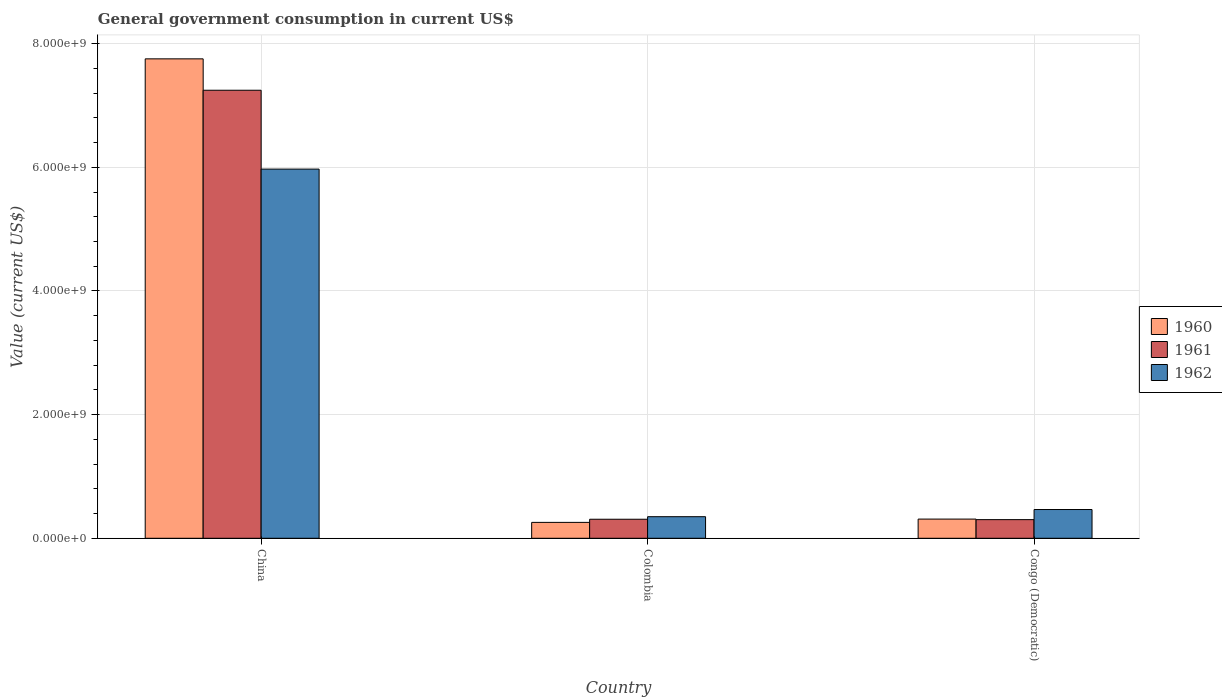How many different coloured bars are there?
Ensure brevity in your answer.  3. Are the number of bars on each tick of the X-axis equal?
Keep it short and to the point. Yes. How many bars are there on the 2nd tick from the right?
Provide a succinct answer. 3. In how many cases, is the number of bars for a given country not equal to the number of legend labels?
Provide a succinct answer. 0. What is the government conusmption in 1962 in Congo (Democratic)?
Give a very brief answer. 4.65e+08. Across all countries, what is the maximum government conusmption in 1960?
Give a very brief answer. 7.75e+09. Across all countries, what is the minimum government conusmption in 1961?
Make the answer very short. 3.02e+08. In which country was the government conusmption in 1960 maximum?
Offer a terse response. China. In which country was the government conusmption in 1961 minimum?
Your answer should be compact. Congo (Democratic). What is the total government conusmption in 1960 in the graph?
Provide a succinct answer. 8.32e+09. What is the difference between the government conusmption in 1960 in China and that in Congo (Democratic)?
Offer a terse response. 7.44e+09. What is the difference between the government conusmption in 1962 in China and the government conusmption in 1960 in Congo (Democratic)?
Offer a very short reply. 5.66e+09. What is the average government conusmption in 1962 per country?
Offer a terse response. 2.26e+09. What is the difference between the government conusmption of/in 1962 and government conusmption of/in 1960 in China?
Your answer should be compact. -1.78e+09. In how many countries, is the government conusmption in 1962 greater than 1600000000 US$?
Keep it short and to the point. 1. What is the ratio of the government conusmption in 1962 in China to that in Congo (Democratic)?
Offer a very short reply. 12.84. Is the difference between the government conusmption in 1962 in Colombia and Congo (Democratic) greater than the difference between the government conusmption in 1960 in Colombia and Congo (Democratic)?
Provide a succinct answer. No. What is the difference between the highest and the second highest government conusmption in 1960?
Keep it short and to the point. 7.44e+09. What is the difference between the highest and the lowest government conusmption in 1962?
Provide a succinct answer. 5.62e+09. In how many countries, is the government conusmption in 1962 greater than the average government conusmption in 1962 taken over all countries?
Your response must be concise. 1. What does the 2nd bar from the left in Colombia represents?
Give a very brief answer. 1961. Is it the case that in every country, the sum of the government conusmption in 1960 and government conusmption in 1962 is greater than the government conusmption in 1961?
Make the answer very short. Yes. Are all the bars in the graph horizontal?
Your answer should be compact. No. How many countries are there in the graph?
Your answer should be very brief. 3. Does the graph contain grids?
Your answer should be compact. Yes. Where does the legend appear in the graph?
Provide a short and direct response. Center right. How many legend labels are there?
Offer a very short reply. 3. What is the title of the graph?
Offer a terse response. General government consumption in current US$. Does "2011" appear as one of the legend labels in the graph?
Make the answer very short. No. What is the label or title of the X-axis?
Make the answer very short. Country. What is the label or title of the Y-axis?
Make the answer very short. Value (current US$). What is the Value (current US$) of 1960 in China?
Offer a terse response. 7.75e+09. What is the Value (current US$) in 1961 in China?
Provide a succinct answer. 7.25e+09. What is the Value (current US$) in 1962 in China?
Offer a terse response. 5.97e+09. What is the Value (current US$) of 1960 in Colombia?
Your response must be concise. 2.57e+08. What is the Value (current US$) of 1961 in Colombia?
Offer a terse response. 3.08e+08. What is the Value (current US$) in 1962 in Colombia?
Offer a very short reply. 3.49e+08. What is the Value (current US$) in 1960 in Congo (Democratic)?
Provide a short and direct response. 3.11e+08. What is the Value (current US$) in 1961 in Congo (Democratic)?
Provide a short and direct response. 3.02e+08. What is the Value (current US$) of 1962 in Congo (Democratic)?
Offer a terse response. 4.65e+08. Across all countries, what is the maximum Value (current US$) of 1960?
Your response must be concise. 7.75e+09. Across all countries, what is the maximum Value (current US$) in 1961?
Your answer should be compact. 7.25e+09. Across all countries, what is the maximum Value (current US$) of 1962?
Provide a short and direct response. 5.97e+09. Across all countries, what is the minimum Value (current US$) in 1960?
Provide a succinct answer. 2.57e+08. Across all countries, what is the minimum Value (current US$) in 1961?
Give a very brief answer. 3.02e+08. Across all countries, what is the minimum Value (current US$) of 1962?
Your answer should be compact. 3.49e+08. What is the total Value (current US$) of 1960 in the graph?
Make the answer very short. 8.32e+09. What is the total Value (current US$) of 1961 in the graph?
Make the answer very short. 7.86e+09. What is the total Value (current US$) in 1962 in the graph?
Your answer should be very brief. 6.79e+09. What is the difference between the Value (current US$) in 1960 in China and that in Colombia?
Provide a succinct answer. 7.50e+09. What is the difference between the Value (current US$) of 1961 in China and that in Colombia?
Your response must be concise. 6.94e+09. What is the difference between the Value (current US$) of 1962 in China and that in Colombia?
Offer a terse response. 5.62e+09. What is the difference between the Value (current US$) in 1960 in China and that in Congo (Democratic)?
Offer a terse response. 7.44e+09. What is the difference between the Value (current US$) of 1961 in China and that in Congo (Democratic)?
Give a very brief answer. 6.95e+09. What is the difference between the Value (current US$) in 1962 in China and that in Congo (Democratic)?
Keep it short and to the point. 5.51e+09. What is the difference between the Value (current US$) in 1960 in Colombia and that in Congo (Democratic)?
Provide a short and direct response. -5.35e+07. What is the difference between the Value (current US$) of 1961 in Colombia and that in Congo (Democratic)?
Keep it short and to the point. 6.24e+06. What is the difference between the Value (current US$) in 1962 in Colombia and that in Congo (Democratic)?
Your answer should be compact. -1.16e+08. What is the difference between the Value (current US$) in 1960 in China and the Value (current US$) in 1961 in Colombia?
Give a very brief answer. 7.45e+09. What is the difference between the Value (current US$) in 1960 in China and the Value (current US$) in 1962 in Colombia?
Keep it short and to the point. 7.41e+09. What is the difference between the Value (current US$) in 1961 in China and the Value (current US$) in 1962 in Colombia?
Make the answer very short. 6.90e+09. What is the difference between the Value (current US$) in 1960 in China and the Value (current US$) in 1961 in Congo (Democratic)?
Offer a terse response. 7.45e+09. What is the difference between the Value (current US$) of 1960 in China and the Value (current US$) of 1962 in Congo (Democratic)?
Your answer should be very brief. 7.29e+09. What is the difference between the Value (current US$) of 1961 in China and the Value (current US$) of 1962 in Congo (Democratic)?
Provide a succinct answer. 6.78e+09. What is the difference between the Value (current US$) of 1960 in Colombia and the Value (current US$) of 1961 in Congo (Democratic)?
Offer a terse response. -4.46e+07. What is the difference between the Value (current US$) in 1960 in Colombia and the Value (current US$) in 1962 in Congo (Democratic)?
Provide a short and direct response. -2.08e+08. What is the difference between the Value (current US$) of 1961 in Colombia and the Value (current US$) of 1962 in Congo (Democratic)?
Your answer should be compact. -1.57e+08. What is the average Value (current US$) in 1960 per country?
Offer a terse response. 2.77e+09. What is the average Value (current US$) in 1961 per country?
Offer a terse response. 2.62e+09. What is the average Value (current US$) in 1962 per country?
Ensure brevity in your answer.  2.26e+09. What is the difference between the Value (current US$) in 1960 and Value (current US$) in 1961 in China?
Your answer should be very brief. 5.08e+08. What is the difference between the Value (current US$) in 1960 and Value (current US$) in 1962 in China?
Your answer should be compact. 1.78e+09. What is the difference between the Value (current US$) of 1961 and Value (current US$) of 1962 in China?
Offer a very short reply. 1.28e+09. What is the difference between the Value (current US$) in 1960 and Value (current US$) in 1961 in Colombia?
Your response must be concise. -5.09e+07. What is the difference between the Value (current US$) of 1960 and Value (current US$) of 1962 in Colombia?
Give a very brief answer. -9.22e+07. What is the difference between the Value (current US$) of 1961 and Value (current US$) of 1962 in Colombia?
Give a very brief answer. -4.13e+07. What is the difference between the Value (current US$) in 1960 and Value (current US$) in 1961 in Congo (Democratic)?
Give a very brief answer. 8.87e+06. What is the difference between the Value (current US$) in 1960 and Value (current US$) in 1962 in Congo (Democratic)?
Give a very brief answer. -1.55e+08. What is the difference between the Value (current US$) of 1961 and Value (current US$) of 1962 in Congo (Democratic)?
Provide a short and direct response. -1.63e+08. What is the ratio of the Value (current US$) of 1960 in China to that in Colombia?
Your answer should be very brief. 30.17. What is the ratio of the Value (current US$) in 1961 in China to that in Colombia?
Your answer should be compact. 23.54. What is the ratio of the Value (current US$) in 1962 in China to that in Colombia?
Your response must be concise. 17.1. What is the ratio of the Value (current US$) of 1960 in China to that in Congo (Democratic)?
Ensure brevity in your answer.  24.97. What is the ratio of the Value (current US$) in 1961 in China to that in Congo (Democratic)?
Offer a terse response. 24.02. What is the ratio of the Value (current US$) of 1962 in China to that in Congo (Democratic)?
Give a very brief answer. 12.84. What is the ratio of the Value (current US$) in 1960 in Colombia to that in Congo (Democratic)?
Your response must be concise. 0.83. What is the ratio of the Value (current US$) of 1961 in Colombia to that in Congo (Democratic)?
Provide a succinct answer. 1.02. What is the ratio of the Value (current US$) of 1962 in Colombia to that in Congo (Democratic)?
Make the answer very short. 0.75. What is the difference between the highest and the second highest Value (current US$) of 1960?
Provide a succinct answer. 7.44e+09. What is the difference between the highest and the second highest Value (current US$) in 1961?
Ensure brevity in your answer.  6.94e+09. What is the difference between the highest and the second highest Value (current US$) of 1962?
Make the answer very short. 5.51e+09. What is the difference between the highest and the lowest Value (current US$) in 1960?
Offer a terse response. 7.50e+09. What is the difference between the highest and the lowest Value (current US$) in 1961?
Keep it short and to the point. 6.95e+09. What is the difference between the highest and the lowest Value (current US$) of 1962?
Your response must be concise. 5.62e+09. 